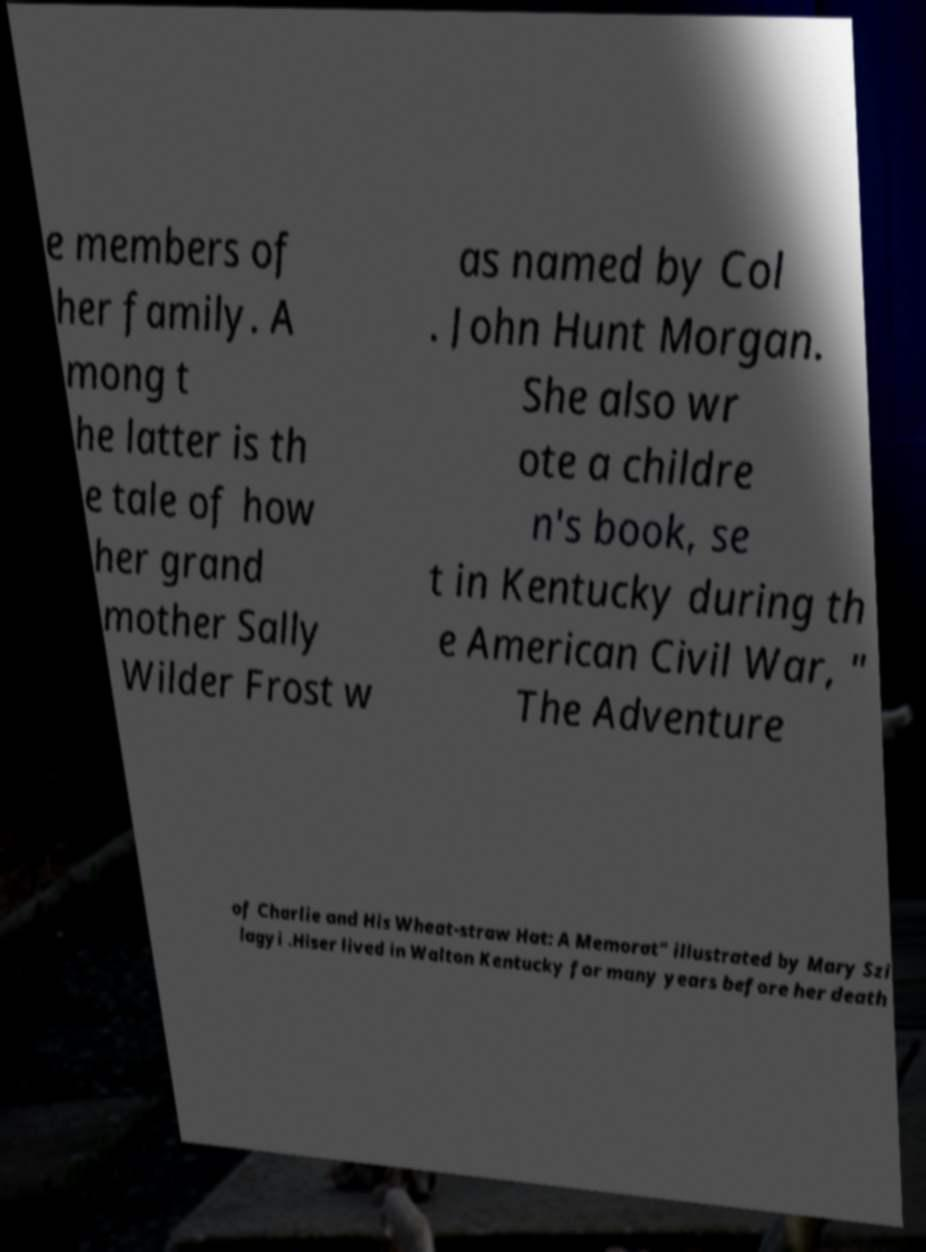Can you read and provide the text displayed in the image?This photo seems to have some interesting text. Can you extract and type it out for me? e members of her family. A mong t he latter is th e tale of how her grand mother Sally Wilder Frost w as named by Col . John Hunt Morgan. She also wr ote a childre n's book, se t in Kentucky during th e American Civil War, " The Adventure of Charlie and His Wheat-straw Hat: A Memorat" illustrated by Mary Szi lagyi .Hiser lived in Walton Kentucky for many years before her death 